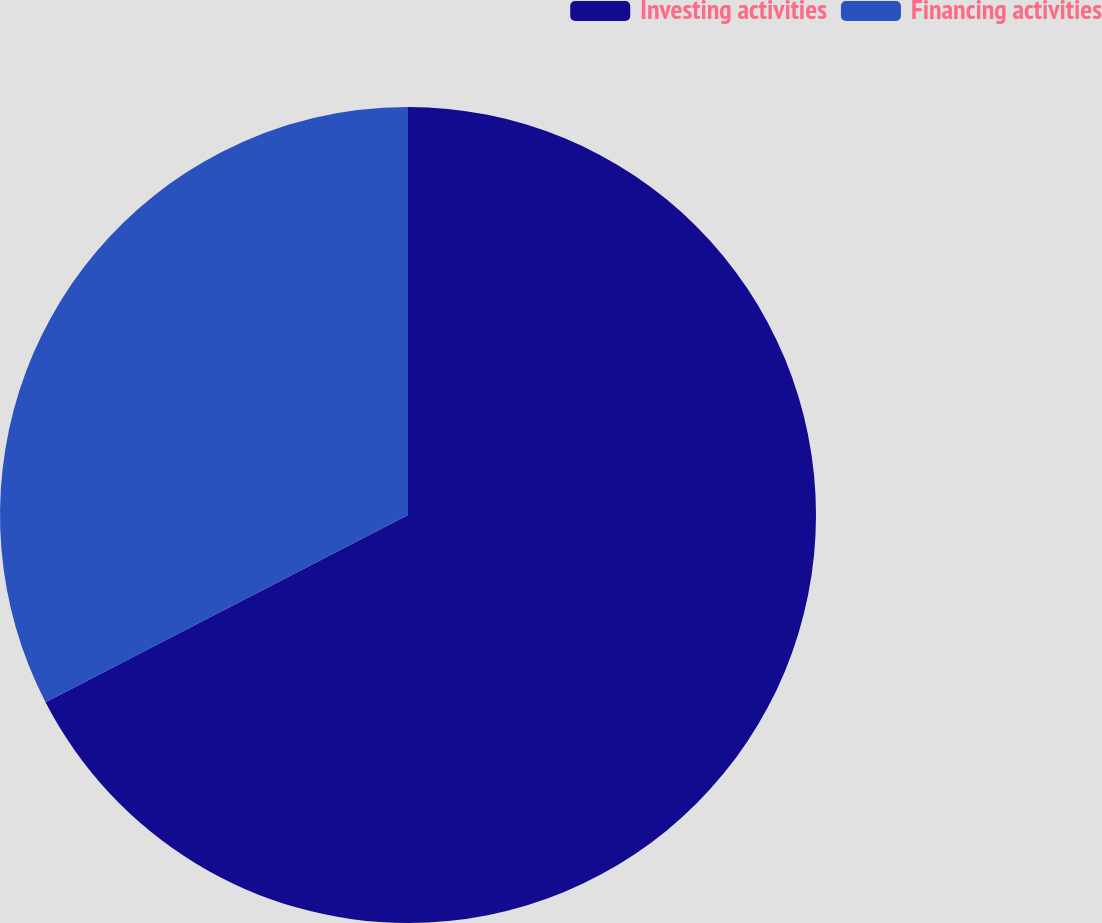Convert chart to OTSL. <chart><loc_0><loc_0><loc_500><loc_500><pie_chart><fcel>Investing activities<fcel>Financing activities<nl><fcel>67.41%<fcel>32.59%<nl></chart> 